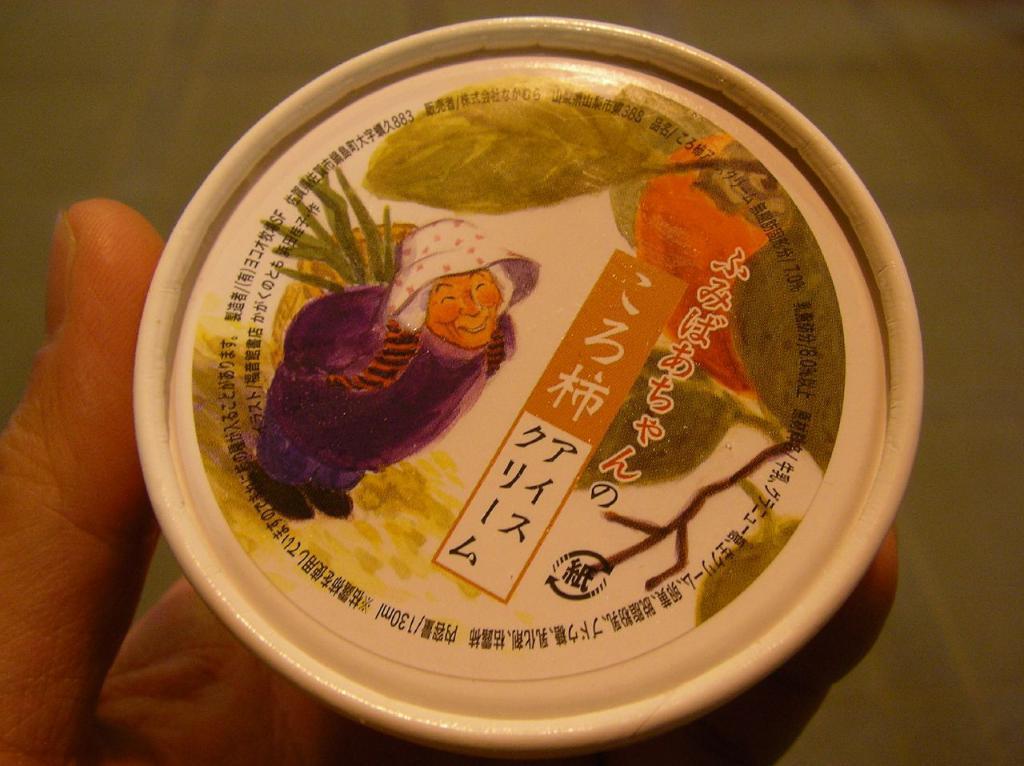Please provide a concise description of this image. In this image we can see some person holding the cup and on the top layer of the cup we can see the depiction of the person and we can also see the text. 